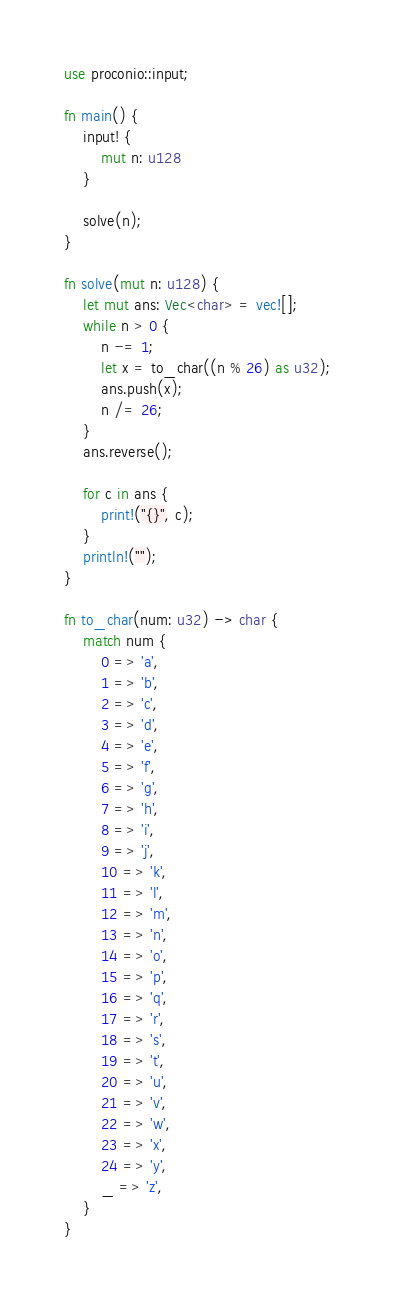<code> <loc_0><loc_0><loc_500><loc_500><_Rust_>use proconio::input;

fn main() {
    input! {
        mut n: u128
    }

    solve(n);
}

fn solve(mut n: u128) {
    let mut ans: Vec<char> = vec![];
    while n > 0 {
        n -= 1;
        let x = to_char((n % 26) as u32);
        ans.push(x);
        n /= 26;
    }
    ans.reverse();

    for c in ans {
        print!("{}", c);
    }
    println!("");
}

fn to_char(num: u32) -> char {
    match num {
        0 => 'a',
        1 => 'b',
        2 => 'c',
        3 => 'd',
        4 => 'e',
        5 => 'f',
        6 => 'g',
        7 => 'h',
        8 => 'i',
        9 => 'j',
        10 => 'k',
        11 => 'l',
        12 => 'm',
        13 => 'n',
        14 => 'o',
        15 => 'p',
        16 => 'q',
        17 => 'r',
        18 => 's',
        19 => 't',
        20 => 'u',
        21 => 'v',
        22 => 'w',
        23 => 'x',
        24 => 'y',
        _ => 'z',
    }
}
</code> 